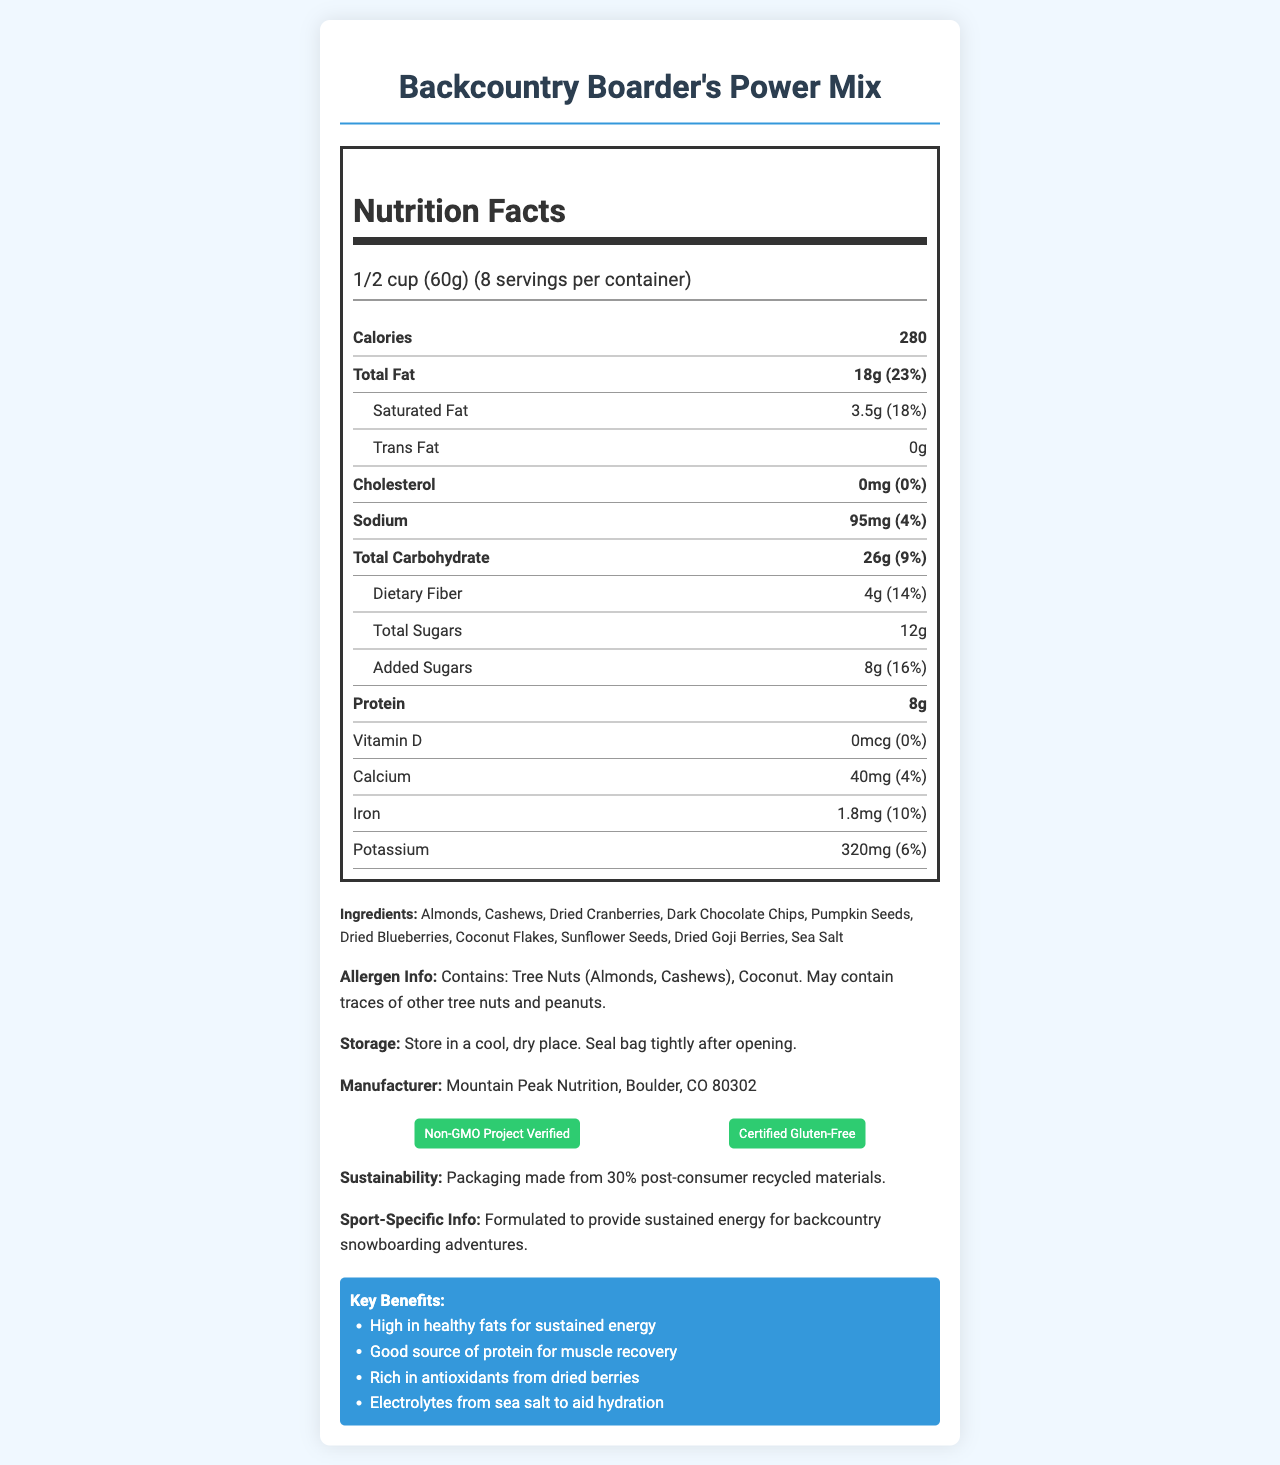what is the name of the product? The product name is clearly stated at the top of the document.
Answer: Backcountry Boarder's Power Mix how many calories are there per serving? The calories per serving are listed in the Nutrition Facts section.
Answer: 280 what is the serving size? The serving size is mentioned in the serving-info section under Nutrition Facts.
Answer: 1/2 cup (60g) what is the total fat content per serving? The total fat content is listed under the Nutrition Facts section as 18g (23% DV).
Answer: 18g how much protein is in each serving? The protein content for each serving is shown as 8g in the Nutrition Facts section.
Answer: 8g which certifications does the product have? A. Non-GMO Project Verified B. USDA Organic C. Certified Gluten-Free D. Fair Trade Certified The product is labeled as Non-GMO Project Verified and Certified Gluten-Free in the certifications section.
Answer: A and C what is the daily value percentage of saturated fat per serving? A. 8% B. 18% C. 23% D. 4% The document states that the saturated fat is 3.5g with a daily value of 18%.
Answer: B is this product suitable for people with tree nut allergies? The allergen information indicates that the product contains tree nuts (Almonds, Cashews) and thus is not suitable for those with tree nut allergies.
Answer: No can we determine if this product is vegan? The document does not provide information related to whether the product is vegan.
Answer: Cannot be determined summarize the main idea of the document. This summary captures all the main sections and types of information included in the document.
Answer: The document provides detailed information about the Backcountry Boarder's Power Mix, a high-energy trail mix designed for backcountry snowboarding. It includes nutrition facts per serving, ingredients, allergen information, storage instructions, manufacturer details, certifications, sustainability notes, sport-specific info, and key benefits. what is the primary benefit of added sea salt in this mix? In the key benefits section, it is mentioned that the sea salt provides electrolytes to aid hydration.
Answer: Electrolytes to aid hydration 